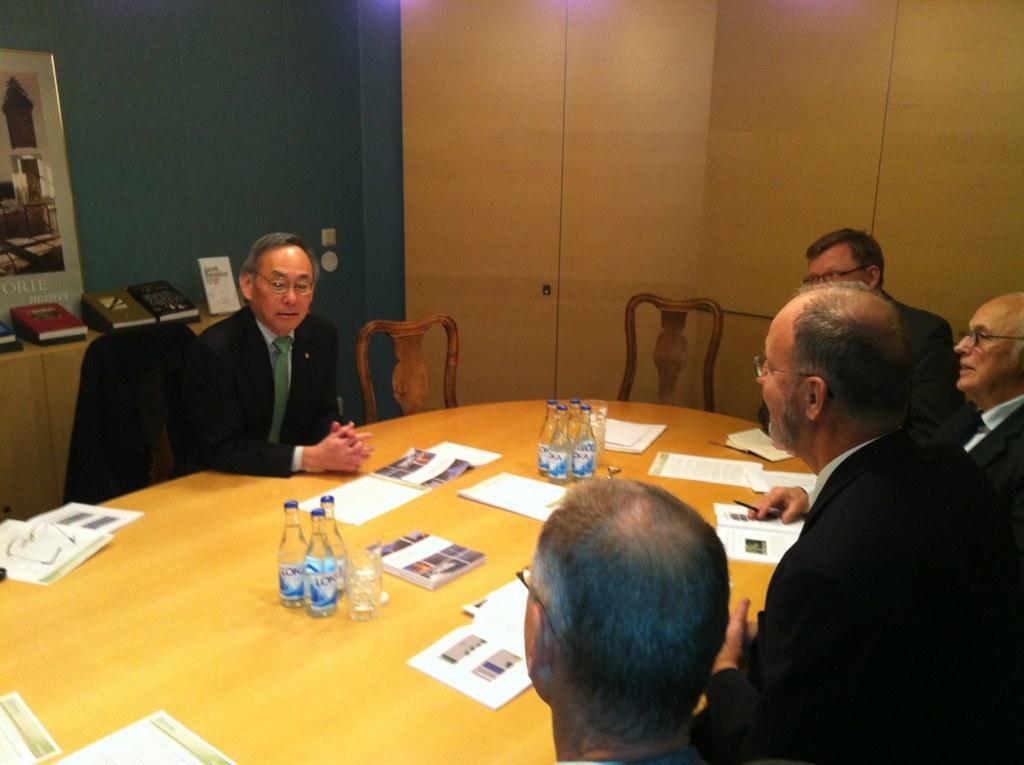How would you summarize this image in a sentence or two? In the image we can see few persons were sitting around the table. On table there is a water bottles,books,papers,glasses etc. In the background we can see wall,photo frames. 